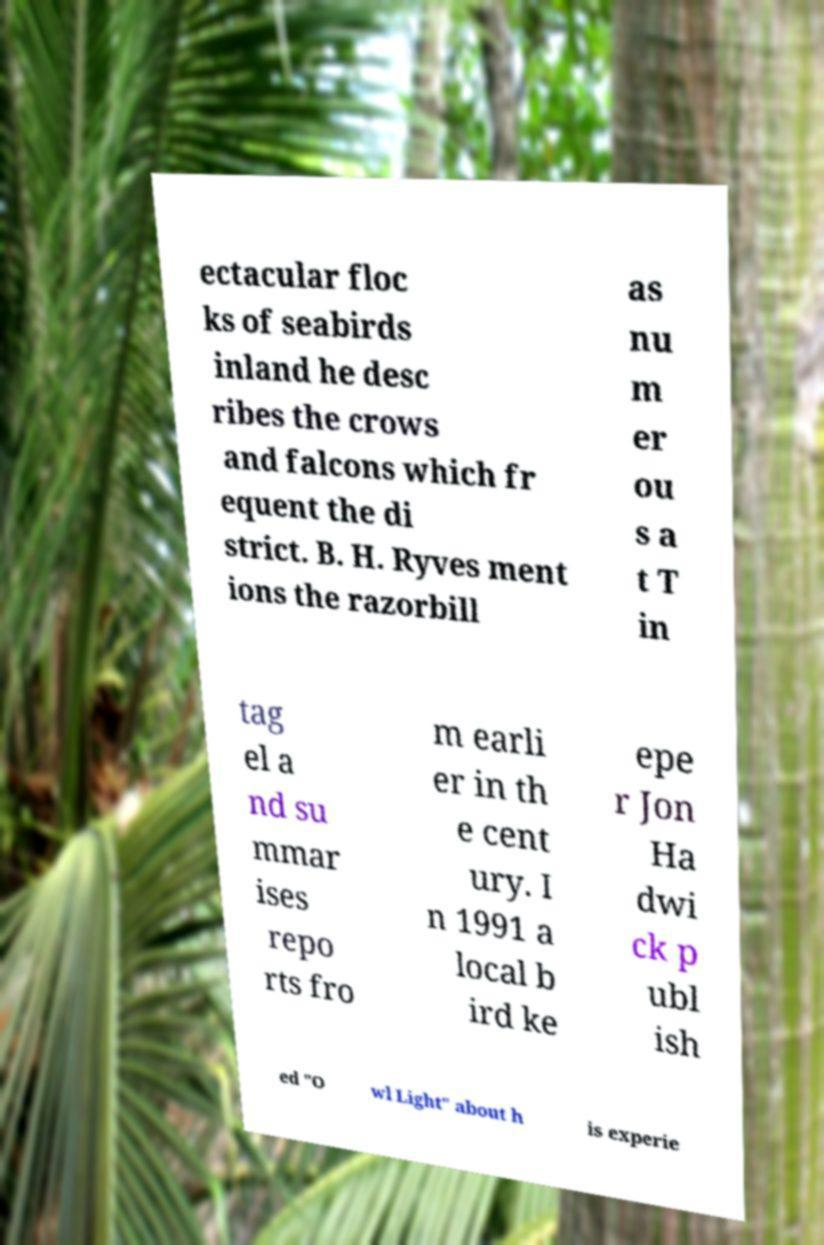Please read and relay the text visible in this image. What does it say? ectacular floc ks of seabirds inland he desc ribes the crows and falcons which fr equent the di strict. B. H. Ryves ment ions the razorbill as nu m er ou s a t T in tag el a nd su mmar ises repo rts fro m earli er in th e cent ury. I n 1991 a local b ird ke epe r Jon Ha dwi ck p ubl ish ed "O wl Light" about h is experie 